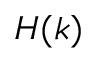Convert formula to latex. <formula><loc_0><loc_0><loc_500><loc_500>H ( k )</formula> 